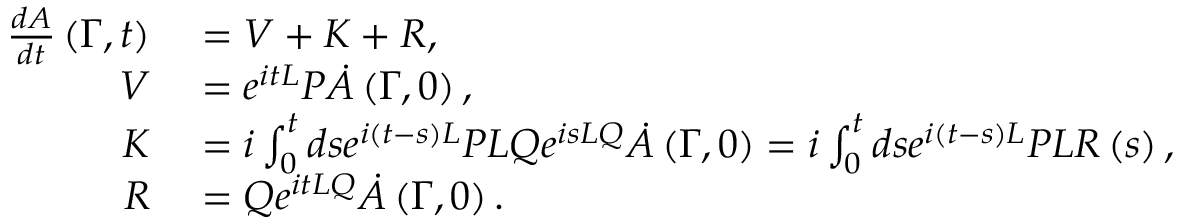<formula> <loc_0><loc_0><loc_500><loc_500>\begin{array} { r l } { { \frac { d A } { d t } } \left ( \Gamma , t \right ) } & = V + K + R , } \\ { V } & = e ^ { i t L } P { \dot { A } } \left ( \Gamma , 0 \right ) , } \\ { K } & = i \int _ { 0 } ^ { t } d s e ^ { i \left ( t - s \right ) L } P L Q e ^ { i s L Q } { \dot { A } } \left ( \Gamma , 0 \right ) = i \int _ { 0 } ^ { t } d s e ^ { i \left ( t - s \right ) L } P L R \left ( s \right ) , } \\ { R } & = Q e ^ { i t L Q } { \dot { A } } \left ( \Gamma , 0 \right ) . } \end{array}</formula> 